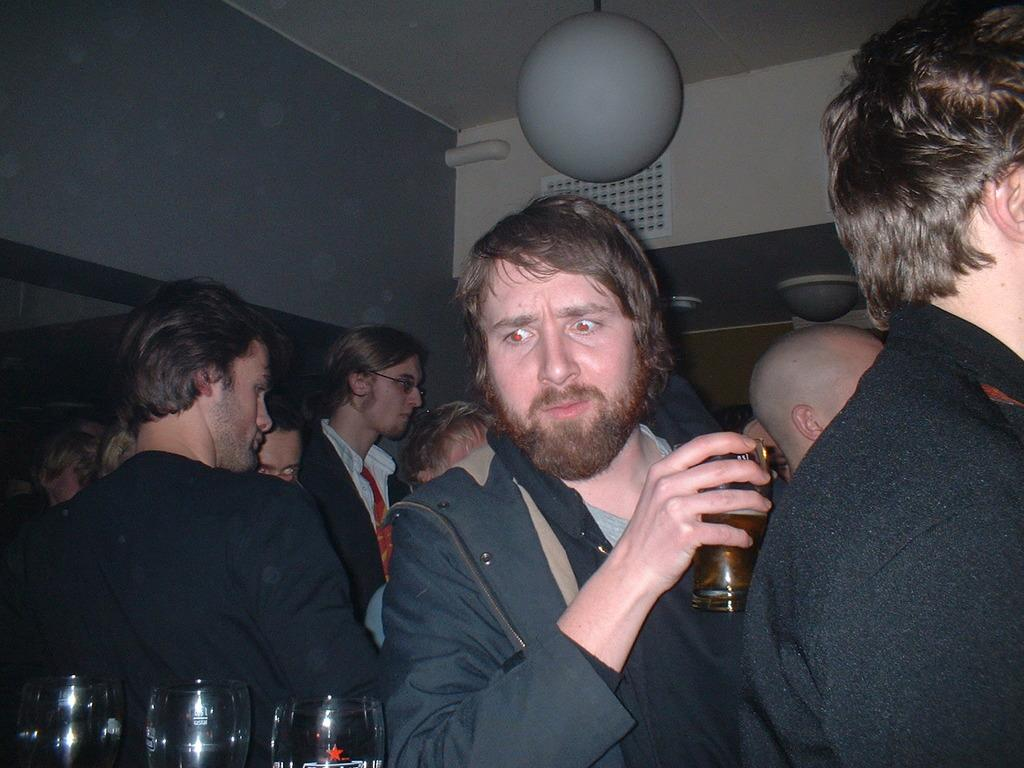How many people are in the image? There is a group of people in the image. What is the man holding in the image? The man is holding a glass in the image. Are there any other glasses visible in the image? Yes, there are glasses in the image. What type of structure can be seen in the image? There are walls and a ceiling in the image. What type of beetle can be seen crawling on the ceiling in the image? There is no beetle present in the image; the ceiling is clear of any insects. What type of cord is connected to the glasses in the image? There are no cords connected to the glasses in the image. 